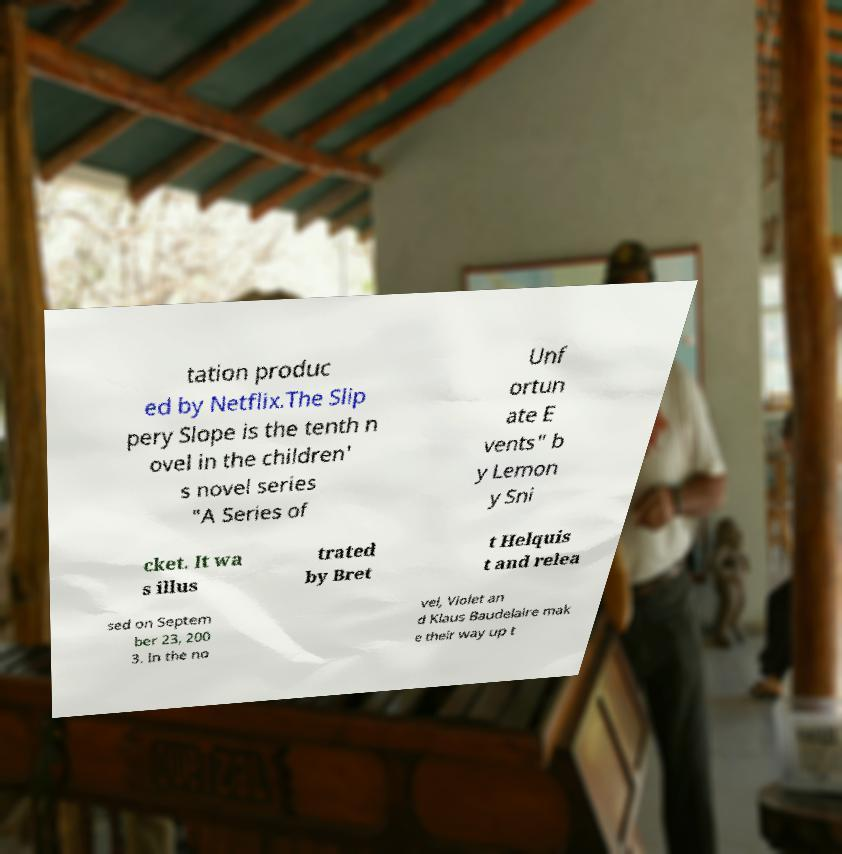For documentation purposes, I need the text within this image transcribed. Could you provide that? tation produc ed by Netflix.The Slip pery Slope is the tenth n ovel in the children' s novel series "A Series of Unf ortun ate E vents" b y Lemon y Sni cket. It wa s illus trated by Bret t Helquis t and relea sed on Septem ber 23, 200 3. In the no vel, Violet an d Klaus Baudelaire mak e their way up t 